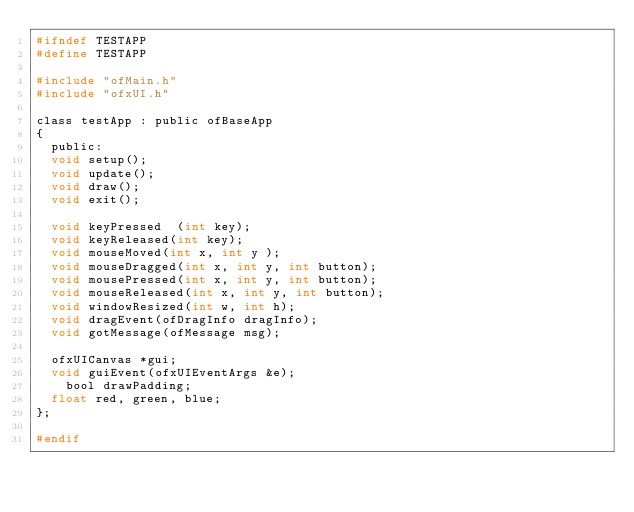Convert code to text. <code><loc_0><loc_0><loc_500><loc_500><_C_>#ifndef TESTAPP
#define TESTAPP

#include "ofMain.h"
#include "ofxUI.h"

class testApp : public ofBaseApp 
{
	public:
	void setup();
	void update();
	void draw();
	void exit(); 

	void keyPressed  (int key);
	void keyReleased(int key);
	void mouseMoved(int x, int y );
	void mouseDragged(int x, int y, int button);
	void mousePressed(int x, int y, int button);
	void mouseReleased(int x, int y, int button);
	void windowResized(int w, int h);
	void dragEvent(ofDragInfo dragInfo);
	void gotMessage(ofMessage msg);
	
	ofxUICanvas *gui;   	
	void guiEvent(ofxUIEventArgs &e);
    bool drawPadding; 
	float red, green, blue; 	
};

#endif</code> 